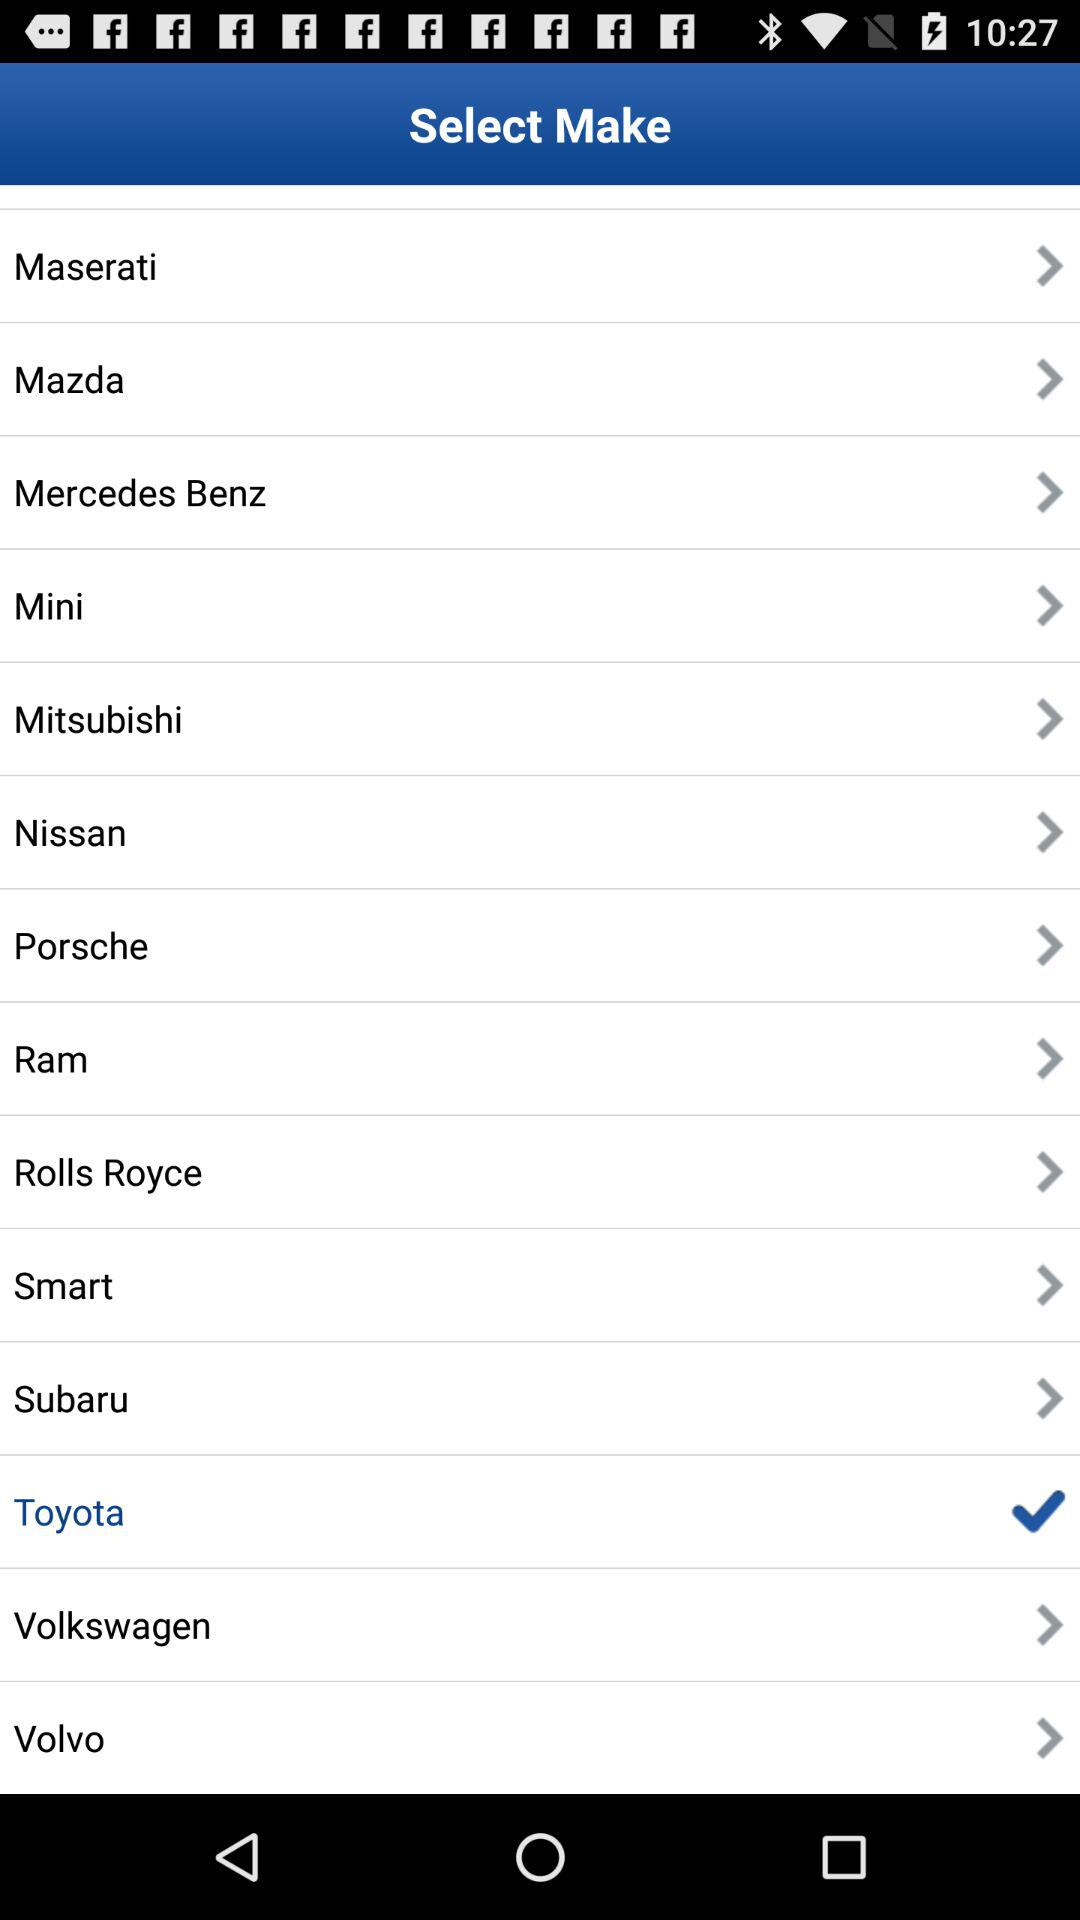How many brands have a checkmark next to them?
Answer the question using a single word or phrase. 1 